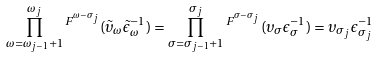<formula> <loc_0><loc_0><loc_500><loc_500>\prod _ { \omega = \omega _ { j - 1 } + 1 } ^ { \omega _ { j } } { ^ { F ^ { \omega - \sigma _ { j } } } ( \tilde { \upsilon } _ { \omega } \tilde { \epsilon } _ { \omega } ^ { - 1 } ) } = \prod _ { \sigma = \sigma _ { j - 1 } + 1 } ^ { \sigma _ { j } } { ^ { F ^ { \sigma - \sigma _ { j } } } ( \upsilon _ { \sigma } \epsilon _ { \sigma } ^ { - 1 } ) } = \upsilon _ { \sigma _ { j } } \epsilon _ { \sigma _ { j } } ^ { - 1 }</formula> 